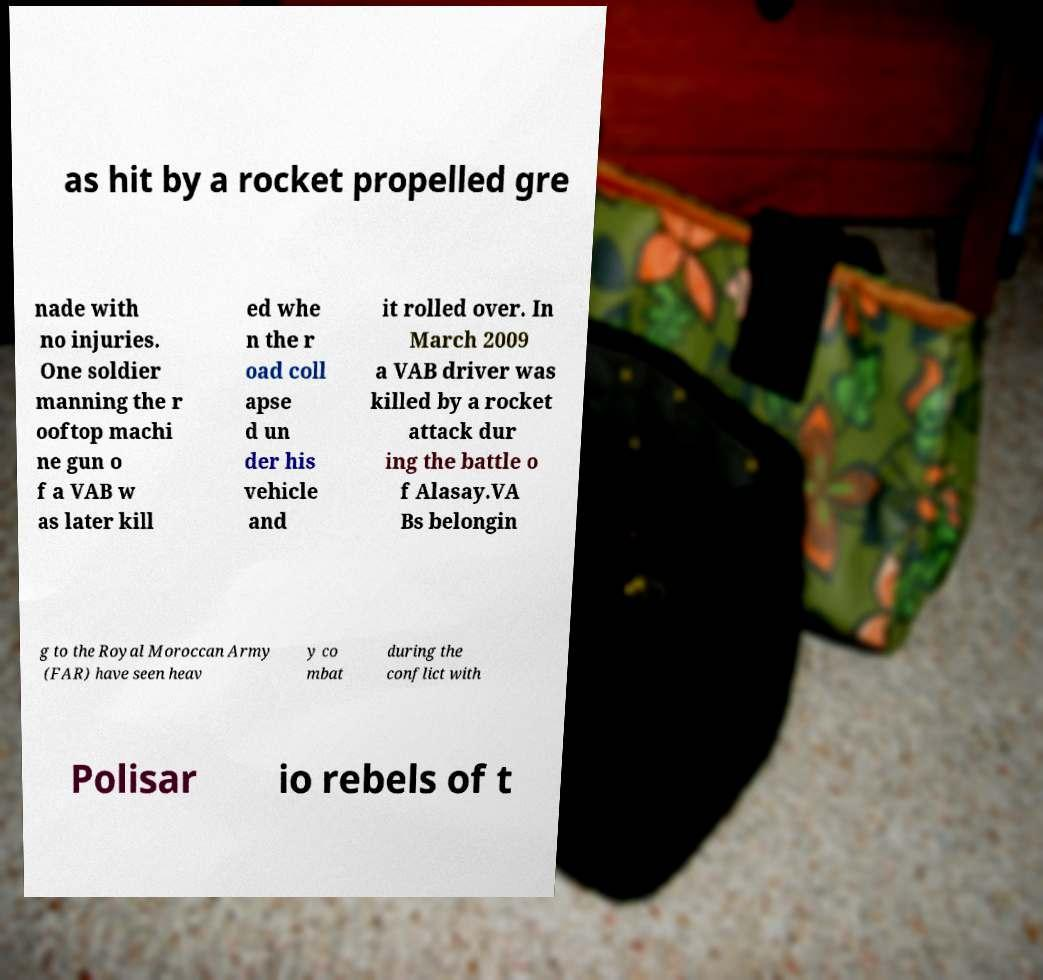There's text embedded in this image that I need extracted. Can you transcribe it verbatim? as hit by a rocket propelled gre nade with no injuries. One soldier manning the r ooftop machi ne gun o f a VAB w as later kill ed whe n the r oad coll apse d un der his vehicle and it rolled over. In March 2009 a VAB driver was killed by a rocket attack dur ing the battle o f Alasay.VA Bs belongin g to the Royal Moroccan Army (FAR) have seen heav y co mbat during the conflict with Polisar io rebels of t 